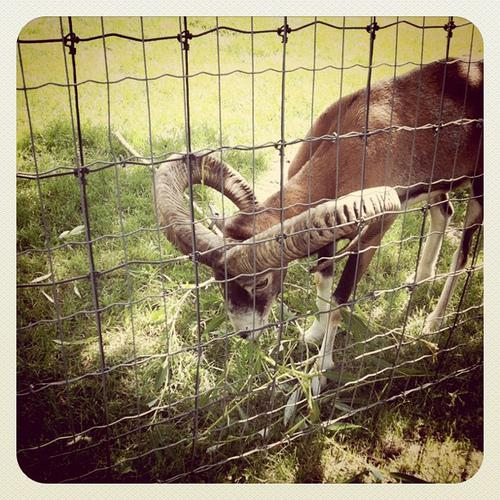Question: where is this taking place?
Choices:
A. At the park.
B. At the zoo.
C. At the beach.
D. In the forest.
Answer with the letter. Answer: B Question: what is in the picture?
Choices:
A. The farm.
B. The stables.
C. The field.
D. The goat.
Answer with the letter. Answer: D Question: what color is the goat?
Choices:
A. Black.
B. Grey.
C. Brown.
D. White.
Answer with the letter. Answer: C Question: when was the picture taken?
Choices:
A. At dusk.
B. During the daytime.
C. At sunrise.
D. At dinnerv.
Answer with the letter. Answer: B Question: how many horns are there?
Choices:
A. 2 horns.
B. 1.
C. 3.
D. 0.
Answer with the letter. Answer: A Question: what is near the goat?
Choices:
A. The barn.
B. The tractor.
C. The food.
D. The fence.
Answer with the letter. Answer: D Question: what color is the fence?
Choices:
A. Black.
B. White.
C. Red.
D. Grey.
Answer with the letter. Answer: D Question: what is the goat eating?
Choices:
A. Grass.
B. Hay.
C. Bugs.
D. Carrots.
Answer with the letter. Answer: A 